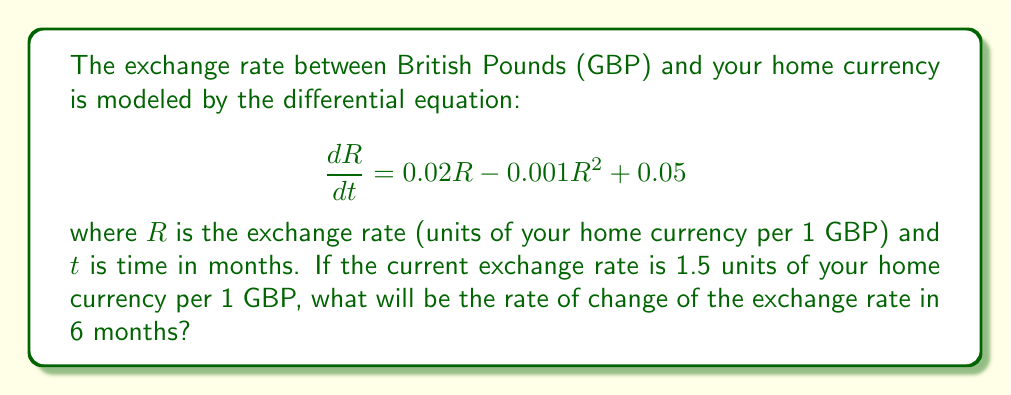What is the answer to this math problem? To solve this problem, we need to follow these steps:

1) The given differential equation is:
   $$\frac{dR}{dt} = 0.02R - 0.001R^2 + 0.05$$

2) We're asked to find $\frac{dR}{dt}$ after 6 months. However, we don't need to solve the differential equation to find $R$ at 6 months. We only need to find $\frac{dR}{dt}$ given the initial $R$.

3) The initial exchange rate is given as 1.5 units of home currency per 1 GBP.

4) To find $\frac{dR}{dt}$ after 6 months, we simply substitute $R = 1.5$ into the differential equation:

   $$\frac{dR}{dt} = 0.02(1.5) - 0.001(1.5)^2 + 0.05$$

5) Let's calculate each term:
   - $0.02(1.5) = 0.03$
   - $0.001(1.5)^2 = 0.001(2.25) = 0.00225$
   - The last term is already 0.05

6) Now, let's substitute these values:

   $$\frac{dR}{dt} = 0.03 - 0.00225 + 0.05$$

7) Finally, let's compute the result:

   $$\frac{dR}{dt} = 0.07775$$

This means the exchange rate is increasing at a rate of approximately 0.07775 units of your home currency per GBP per month.
Answer: $\frac{dR}{dt} = 0.07775$ units of home currency per GBP per month 